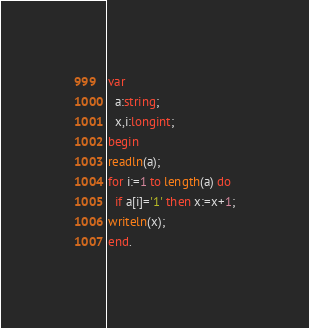<code> <loc_0><loc_0><loc_500><loc_500><_Pascal_>var
  a:string;
  x,i:longint;
begin
readln(a);
for i:=1 to length(a) do
  if a[i]='1' then x:=x+1;
writeln(x);
end.</code> 